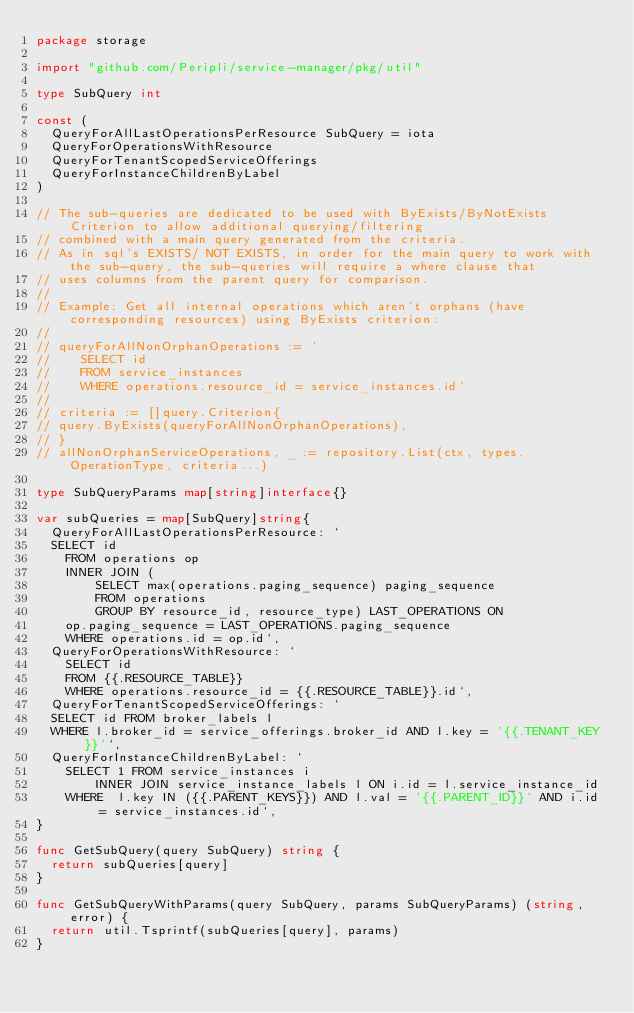<code> <loc_0><loc_0><loc_500><loc_500><_Go_>package storage

import "github.com/Peripli/service-manager/pkg/util"

type SubQuery int

const (
	QueryForAllLastOperationsPerResource SubQuery = iota
	QueryForOperationsWithResource
	QueryForTenantScopedServiceOfferings
	QueryForInstanceChildrenByLabel
)

// The sub-queries are dedicated to be used with ByExists/ByNotExists Criterion to allow additional querying/filtering
// combined with a main query generated from the criteria.
// As in sql's EXISTS/ NOT EXISTS, in order for the main query to work with the sub-query, the sub-queries will require a where clause that
// uses columns from the parent query for comparison.
//
// Example: Get all internal operations which aren't orphans (have corresponding resources) using ByExists criterion:
//
// queryForAllNonOrphanOperations := `
//    SELECT id
//    FROM service_instances
//	  WHERE operations.resource_id = service_instances.id`
//
// criteria := []query.Criterion{
// query.ByExists(queryForAllNonOrphanOperations),
// }
// allNonOrphanServiceOperations, _ := repository.List(ctx, types.OperationType, criteria...)

type SubQueryParams map[string]interface{}

var subQueries = map[SubQuery]string{
	QueryForAllLastOperationsPerResource: `
	SELECT id
    FROM operations op
    INNER JOIN (
        SELECT max(operations.paging_sequence) paging_sequence
        FROM operations
        GROUP BY resource_id, resource_type) LAST_OPERATIONS ON 
    op.paging_sequence = LAST_OPERATIONS.paging_sequence
    WHERE operations.id = op.id`,
	QueryForOperationsWithResource: `
    SELECT id
    FROM {{.RESOURCE_TABLE}}
    WHERE operations.resource_id = {{.RESOURCE_TABLE}}.id`,
	QueryForTenantScopedServiceOfferings: `
	SELECT id FROM broker_labels l
	WHERE l.broker_id = service_offerings.broker_id AND l.key = '{{.TENANT_KEY}}'`,
	QueryForInstanceChildrenByLabel: `
		SELECT 1 FROM service_instances i
        INNER JOIN service_instance_labels l ON i.id = l.service_instance_id
		WHERE  l.key IN ({{.PARENT_KEYS}}) AND l.val = '{{.PARENT_ID}}' AND i.id = service_instances.id`,
}

func GetSubQuery(query SubQuery) string {
	return subQueries[query]
}

func GetSubQueryWithParams(query SubQuery, params SubQueryParams) (string, error) {
	return util.Tsprintf(subQueries[query], params)
}
</code> 